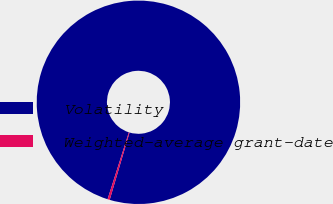Convert chart. <chart><loc_0><loc_0><loc_500><loc_500><pie_chart><fcel>Volatility<fcel>Weighted-average grant-date<nl><fcel>99.65%<fcel>0.35%<nl></chart> 